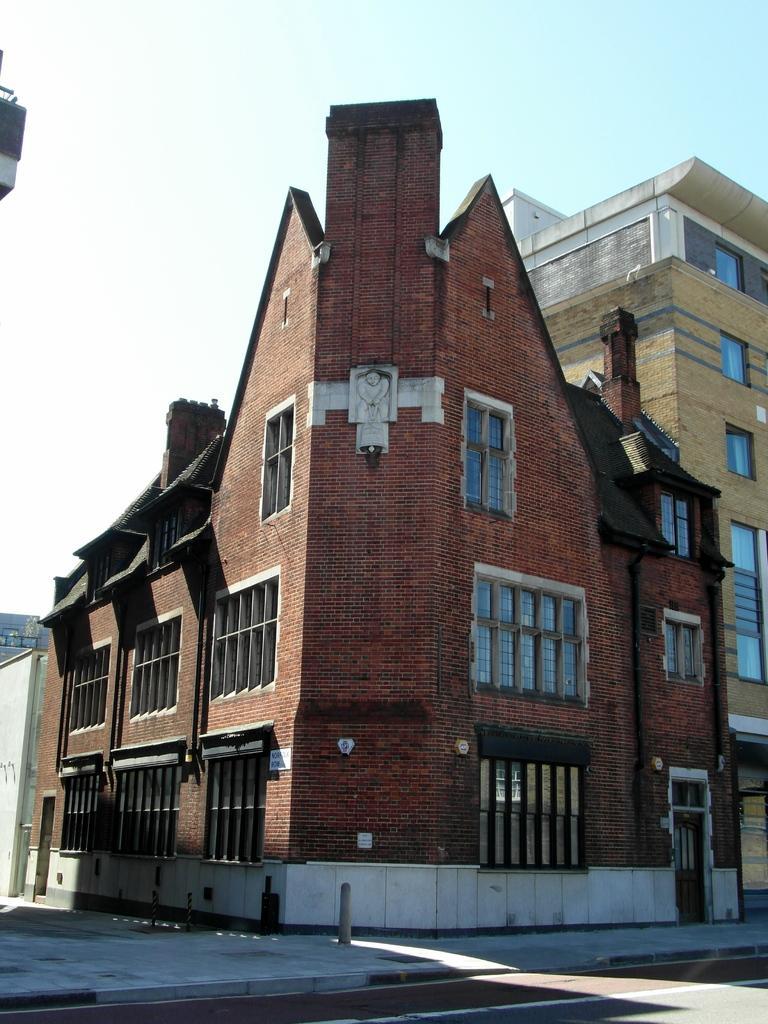How would you summarize this image in a sentence or two? This is an outside view. At the bottom there is a road. In the middle of the image I can see few buildings along with the windows. At the top of the image I can see the sky. 